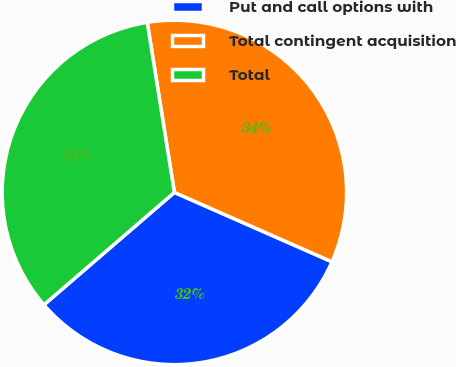Convert chart. <chart><loc_0><loc_0><loc_500><loc_500><pie_chart><fcel>Put and call options with<fcel>Total contingent acquisition<fcel>Total<nl><fcel>32.08%<fcel>34.12%<fcel>33.8%<nl></chart> 